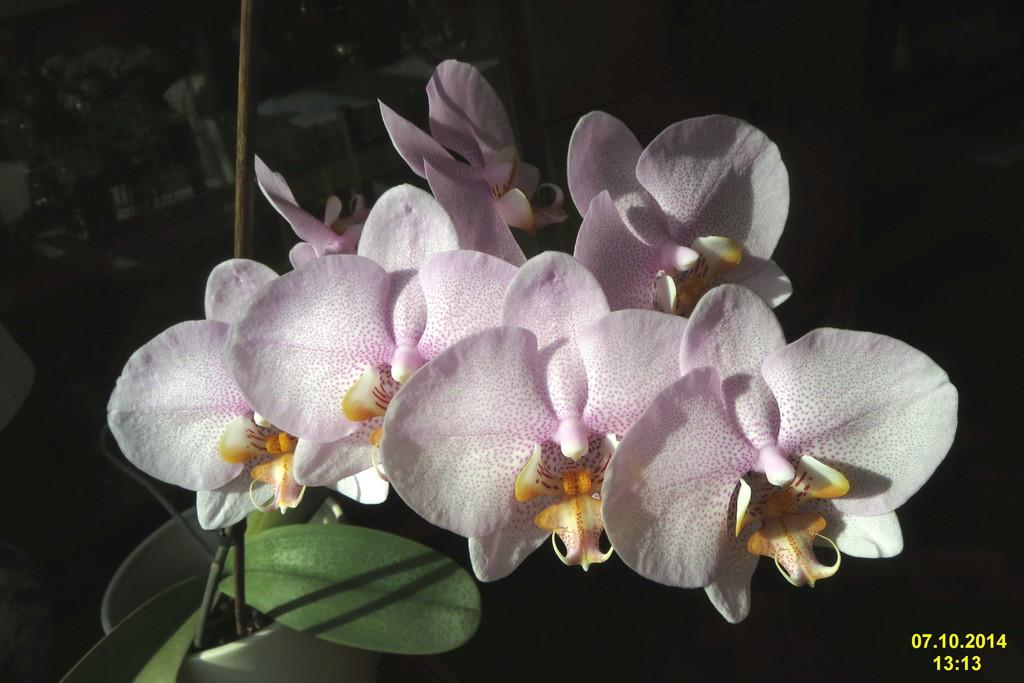What type of plants are in the image? There are flowers in the image. What color are the flowers? The flowers are in light pink color. What else can be seen in the image besides the flowers? There are leaves in the image. What color are the leaves? The leaves are in green color. How would you describe the overall appearance of the image? The background of the image is dark. How many pears are hanging from the thread in the image? There are no pears or thread present in the image. What type of rest can be seen in the image? There is no rest or resting area depicted in the image; it features flowers and leaves. 